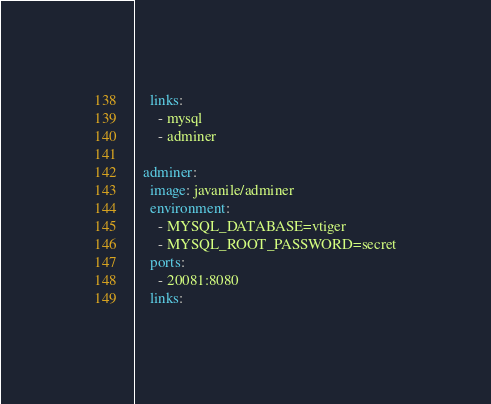<code> <loc_0><loc_0><loc_500><loc_500><_YAML_>    links:
      - mysql
      - adminer

  adminer:
    image: javanile/adminer
    environment:
      - MYSQL_DATABASE=vtiger
      - MYSQL_ROOT_PASSWORD=secret
    ports:
      - 20081:8080
    links:</code> 